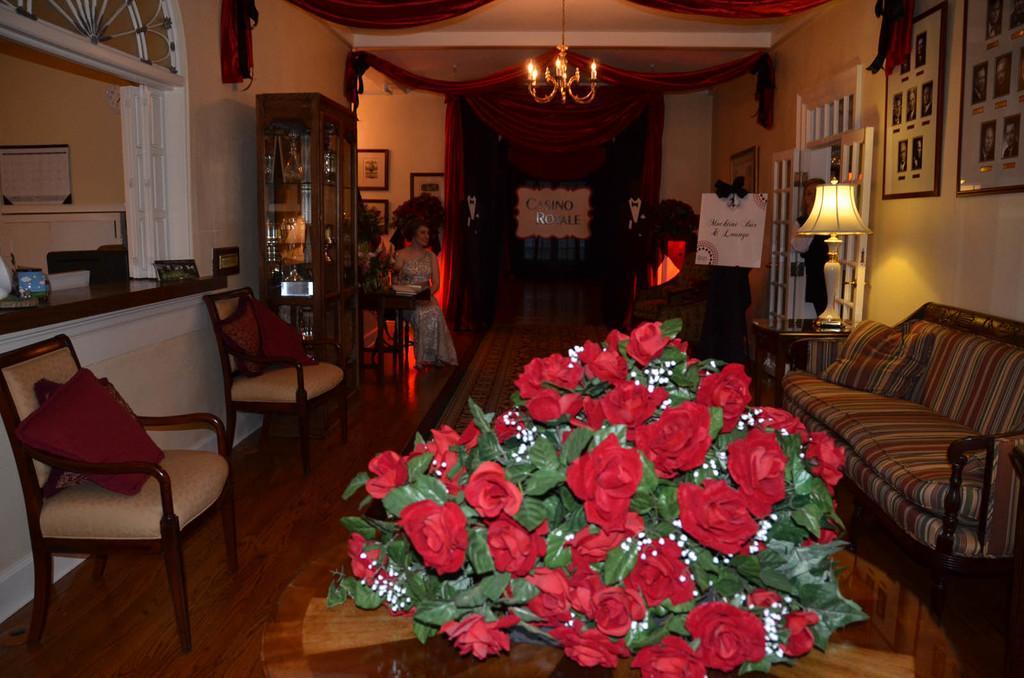How would you summarize this image in a sentence or two? In this picture we can see a sofa and some chairs near the desk and a shelf where some things are placed and a lady sitting in the corner and some red flowers and some photo frames to the wall and a lamp. 